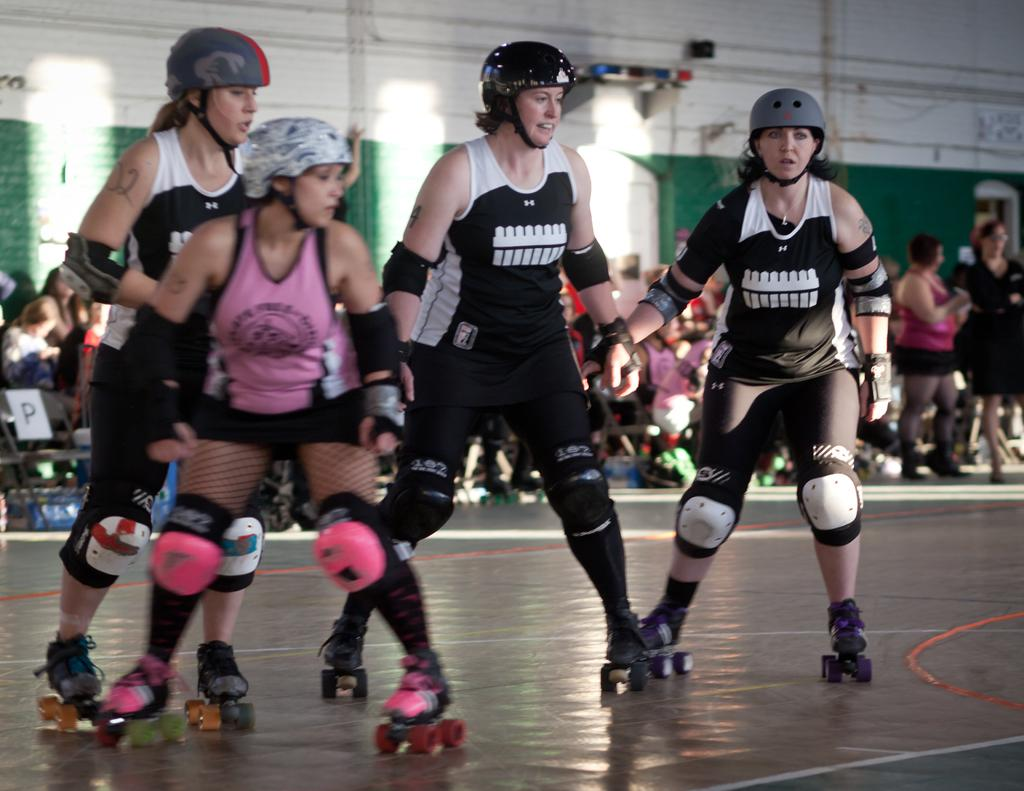How many women are in the image? There are four women in the image. What are the women doing in the image? The women are skating on the floor. What type of shoes are the women wearing? The women are wearing skate shoes. What can be seen in the background of the image? There are people, chairs, a wall, lights, and pipes in the background of the image. What low-frequency sound can be heard in the image? There is no sound present in the image, so it is not possible to determine the frequency of any sounds. 